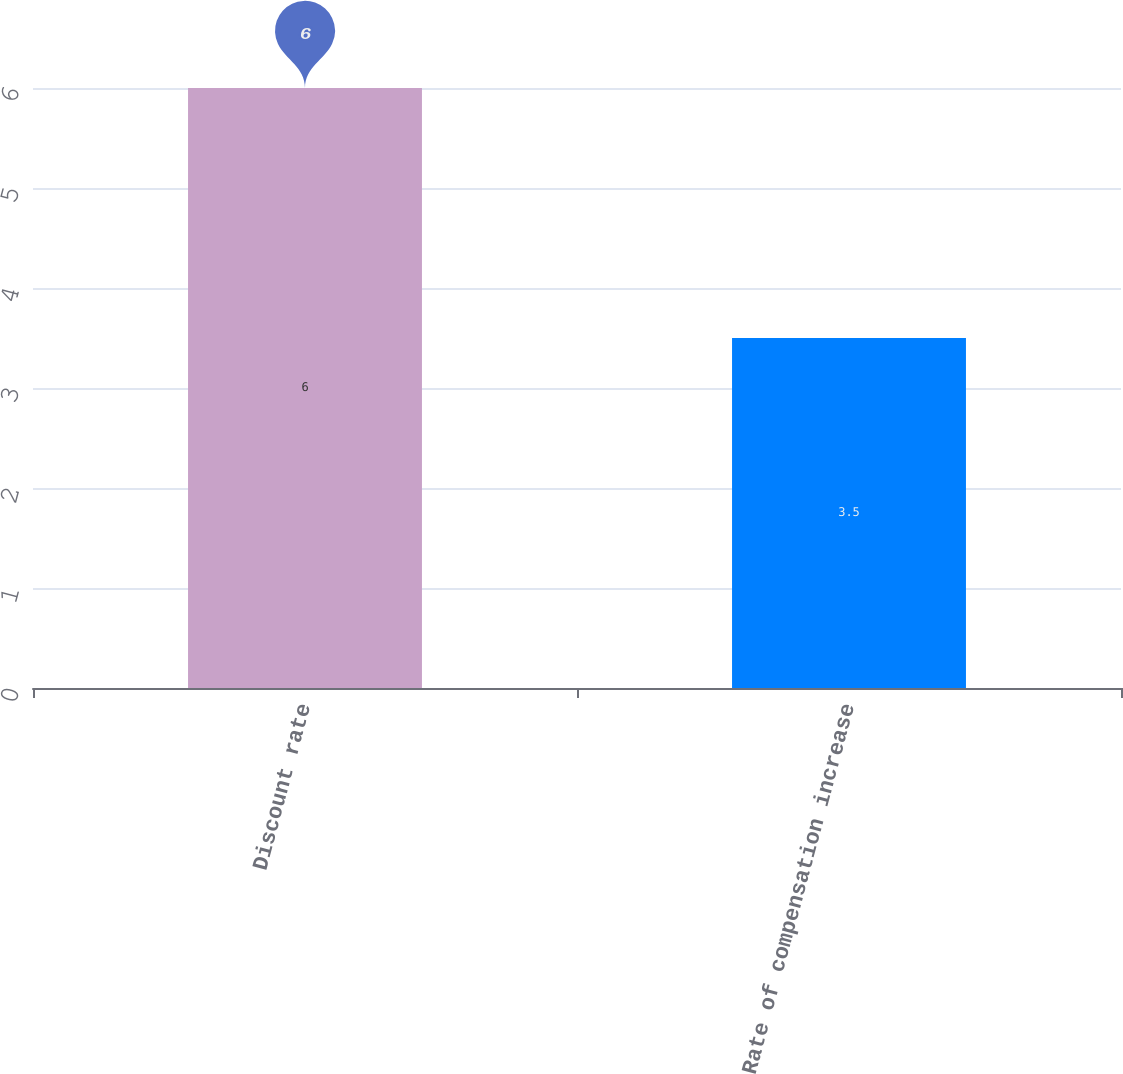<chart> <loc_0><loc_0><loc_500><loc_500><bar_chart><fcel>Discount rate<fcel>Rate of compensation increase<nl><fcel>6<fcel>3.5<nl></chart> 